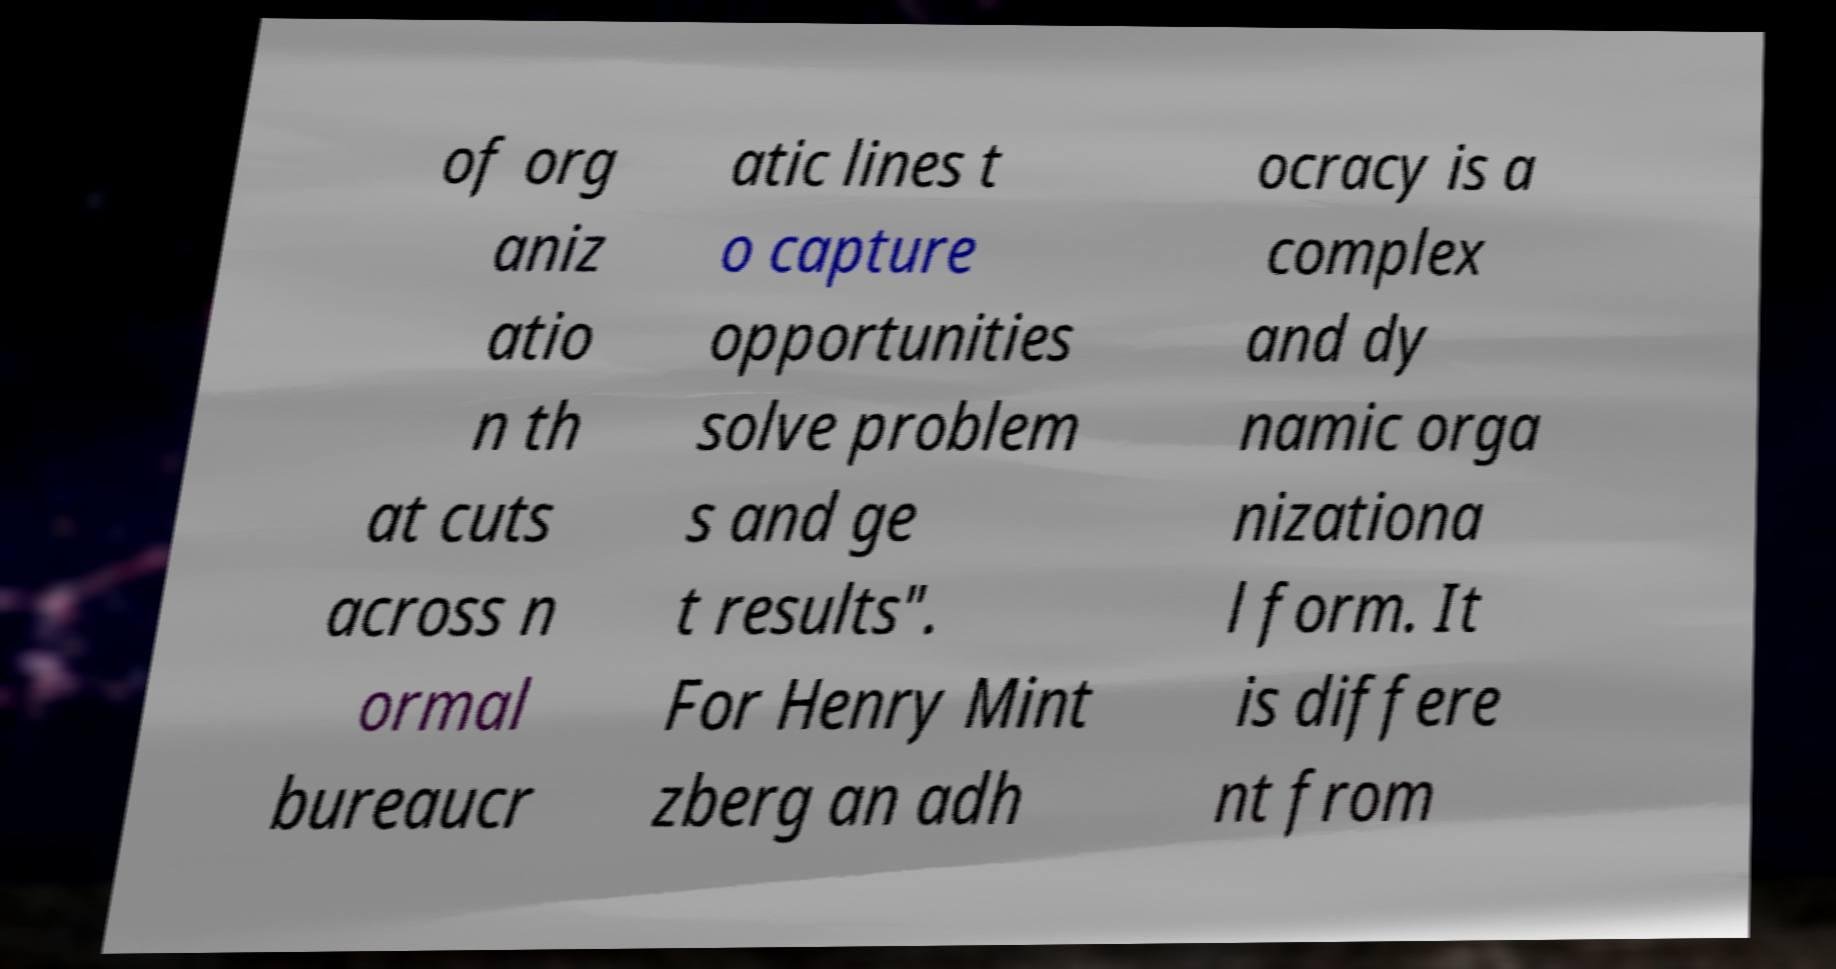There's text embedded in this image that I need extracted. Can you transcribe it verbatim? of org aniz atio n th at cuts across n ormal bureaucr atic lines t o capture opportunities solve problem s and ge t results". For Henry Mint zberg an adh ocracy is a complex and dy namic orga nizationa l form. It is differe nt from 